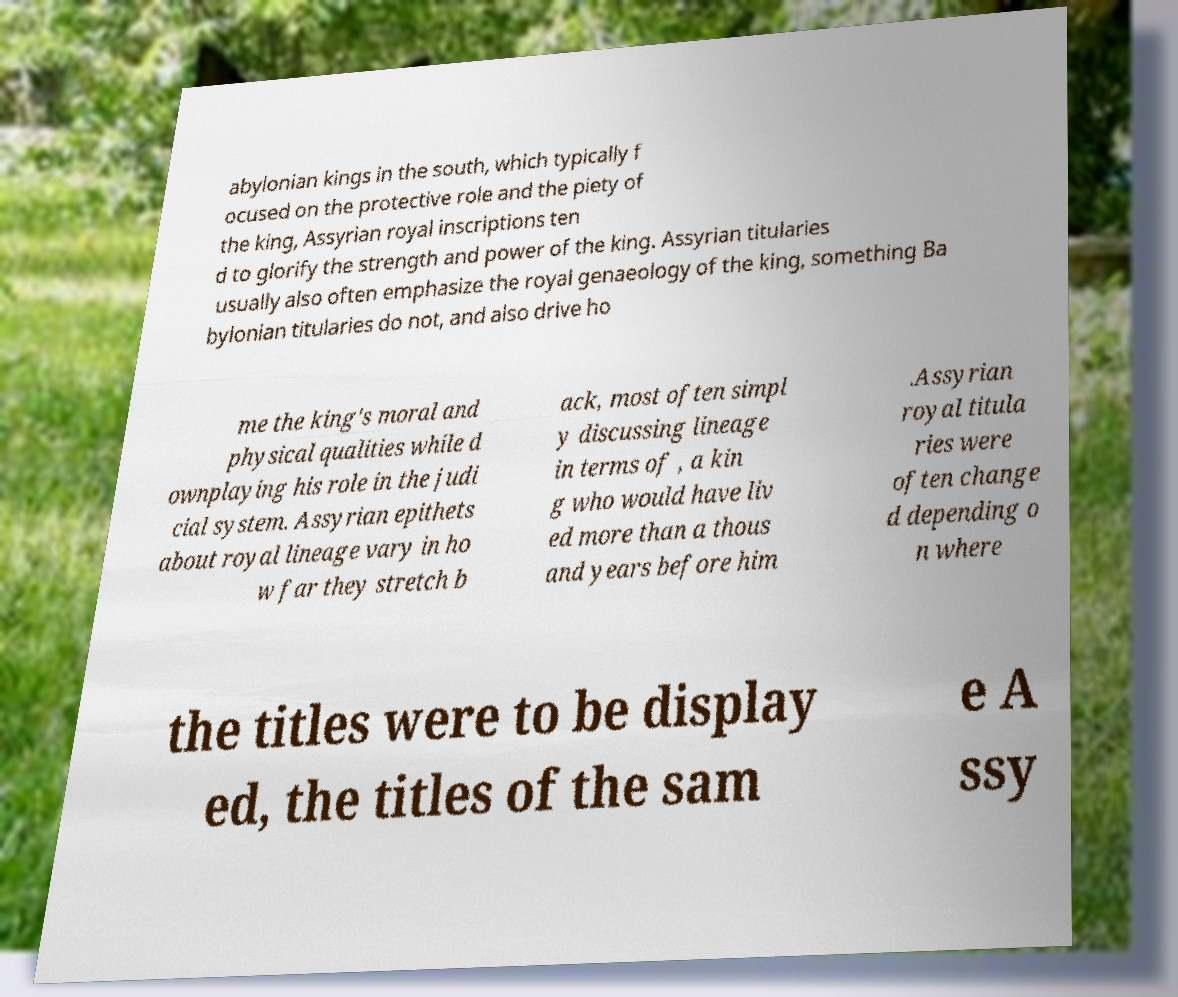I need the written content from this picture converted into text. Can you do that? abylonian kings in the south, which typically f ocused on the protective role and the piety of the king, Assyrian royal inscriptions ten d to glorify the strength and power of the king. Assyrian titularies usually also often emphasize the royal genaeology of the king, something Ba bylonian titularies do not, and also drive ho me the king's moral and physical qualities while d ownplaying his role in the judi cial system. Assyrian epithets about royal lineage vary in ho w far they stretch b ack, most often simpl y discussing lineage in terms of , a kin g who would have liv ed more than a thous and years before him .Assyrian royal titula ries were often change d depending o n where the titles were to be display ed, the titles of the sam e A ssy 